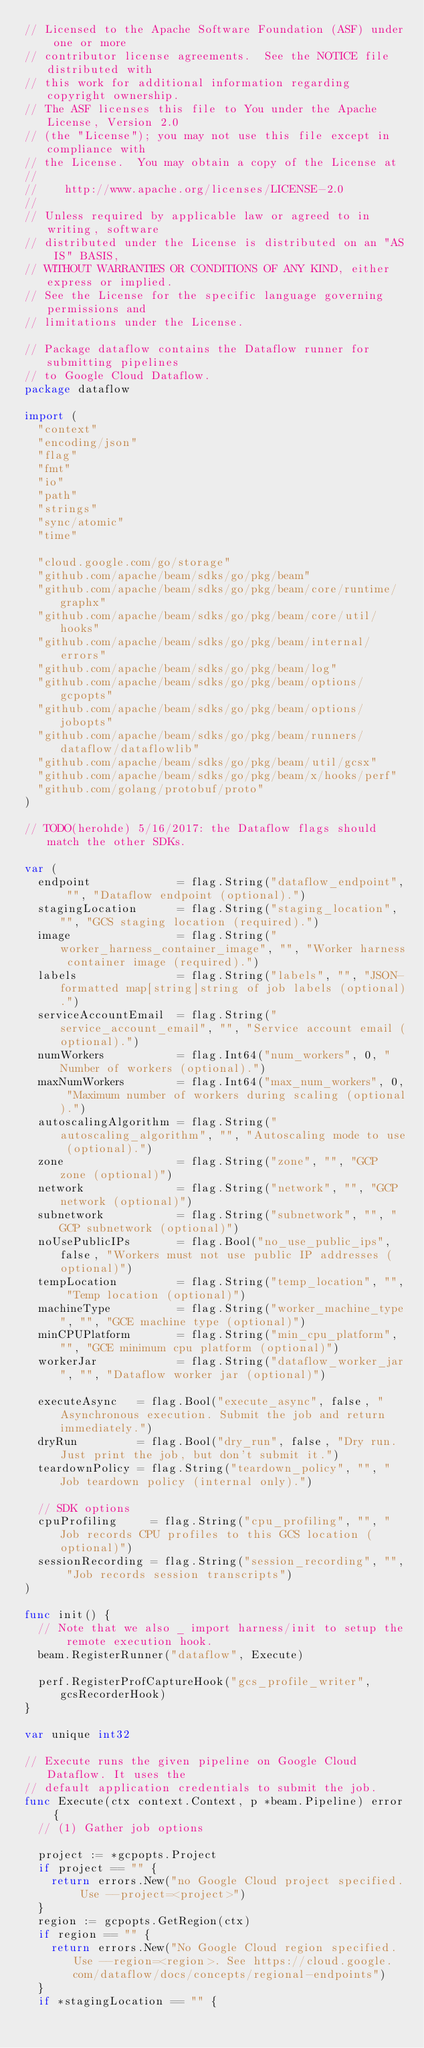Convert code to text. <code><loc_0><loc_0><loc_500><loc_500><_Go_>// Licensed to the Apache Software Foundation (ASF) under one or more
// contributor license agreements.  See the NOTICE file distributed with
// this work for additional information regarding copyright ownership.
// The ASF licenses this file to You under the Apache License, Version 2.0
// (the "License"); you may not use this file except in compliance with
// the License.  You may obtain a copy of the License at
//
//    http://www.apache.org/licenses/LICENSE-2.0
//
// Unless required by applicable law or agreed to in writing, software
// distributed under the License is distributed on an "AS IS" BASIS,
// WITHOUT WARRANTIES OR CONDITIONS OF ANY KIND, either express or implied.
// See the License for the specific language governing permissions and
// limitations under the License.

// Package dataflow contains the Dataflow runner for submitting pipelines
// to Google Cloud Dataflow.
package dataflow

import (
	"context"
	"encoding/json"
	"flag"
	"fmt"
	"io"
	"path"
	"strings"
	"sync/atomic"
	"time"

	"cloud.google.com/go/storage"
	"github.com/apache/beam/sdks/go/pkg/beam"
	"github.com/apache/beam/sdks/go/pkg/beam/core/runtime/graphx"
	"github.com/apache/beam/sdks/go/pkg/beam/core/util/hooks"
	"github.com/apache/beam/sdks/go/pkg/beam/internal/errors"
	"github.com/apache/beam/sdks/go/pkg/beam/log"
	"github.com/apache/beam/sdks/go/pkg/beam/options/gcpopts"
	"github.com/apache/beam/sdks/go/pkg/beam/options/jobopts"
	"github.com/apache/beam/sdks/go/pkg/beam/runners/dataflow/dataflowlib"
	"github.com/apache/beam/sdks/go/pkg/beam/util/gcsx"
	"github.com/apache/beam/sdks/go/pkg/beam/x/hooks/perf"
	"github.com/golang/protobuf/proto"
)

// TODO(herohde) 5/16/2017: the Dataflow flags should match the other SDKs.

var (
	endpoint             = flag.String("dataflow_endpoint", "", "Dataflow endpoint (optional).")
	stagingLocation      = flag.String("staging_location", "", "GCS staging location (required).")
	image                = flag.String("worker_harness_container_image", "", "Worker harness container image (required).")
	labels               = flag.String("labels", "", "JSON-formatted map[string]string of job labels (optional).")
	serviceAccountEmail  = flag.String("service_account_email", "", "Service account email (optional).")
	numWorkers           = flag.Int64("num_workers", 0, "Number of workers (optional).")
	maxNumWorkers        = flag.Int64("max_num_workers", 0, "Maximum number of workers during scaling (optional).")
	autoscalingAlgorithm = flag.String("autoscaling_algorithm", "", "Autoscaling mode to use (optional).")
	zone                 = flag.String("zone", "", "GCP zone (optional)")
	network              = flag.String("network", "", "GCP network (optional)")
	subnetwork           = flag.String("subnetwork", "", "GCP subnetwork (optional)")
	noUsePublicIPs       = flag.Bool("no_use_public_ips", false, "Workers must not use public IP addresses (optional)")
	tempLocation         = flag.String("temp_location", "", "Temp location (optional)")
	machineType          = flag.String("worker_machine_type", "", "GCE machine type (optional)")
	minCPUPlatform       = flag.String("min_cpu_platform", "", "GCE minimum cpu platform (optional)")
	workerJar            = flag.String("dataflow_worker_jar", "", "Dataflow worker jar (optional)")

	executeAsync   = flag.Bool("execute_async", false, "Asynchronous execution. Submit the job and return immediately.")
	dryRun         = flag.Bool("dry_run", false, "Dry run. Just print the job, but don't submit it.")
	teardownPolicy = flag.String("teardown_policy", "", "Job teardown policy (internal only).")

	// SDK options
	cpuProfiling     = flag.String("cpu_profiling", "", "Job records CPU profiles to this GCS location (optional)")
	sessionRecording = flag.String("session_recording", "", "Job records session transcripts")
)

func init() {
	// Note that we also _ import harness/init to setup the remote execution hook.
	beam.RegisterRunner("dataflow", Execute)

	perf.RegisterProfCaptureHook("gcs_profile_writer", gcsRecorderHook)
}

var unique int32

// Execute runs the given pipeline on Google Cloud Dataflow. It uses the
// default application credentials to submit the job.
func Execute(ctx context.Context, p *beam.Pipeline) error {
	// (1) Gather job options

	project := *gcpopts.Project
	if project == "" {
		return errors.New("no Google Cloud project specified. Use --project=<project>")
	}
	region := gcpopts.GetRegion(ctx)
	if region == "" {
		return errors.New("No Google Cloud region specified. Use --region=<region>. See https://cloud.google.com/dataflow/docs/concepts/regional-endpoints")
	}
	if *stagingLocation == "" {</code> 